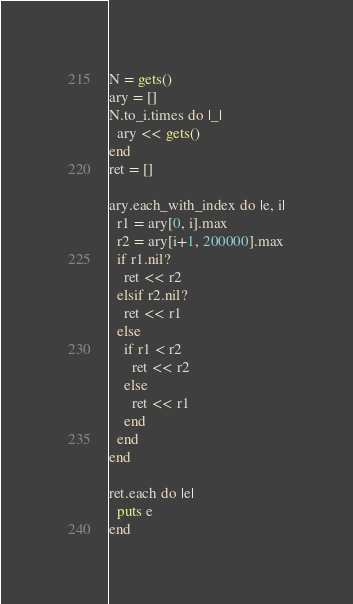Convert code to text. <code><loc_0><loc_0><loc_500><loc_500><_Crystal_>N = gets()
ary = []
N.to_i.times do |_|
  ary << gets()
end
ret = []

ary.each_with_index do |e, i|
  r1 = ary[0, i].max
  r2 = ary[i+1, 200000].max
  if r1.nil?
    ret << r2
  elsif r2.nil?
    ret << r1
  else
    if r1 < r2
      ret << r2
    else
      ret << r1
    end
  end
end  

ret.each do |e|
  puts e
end               

</code> 